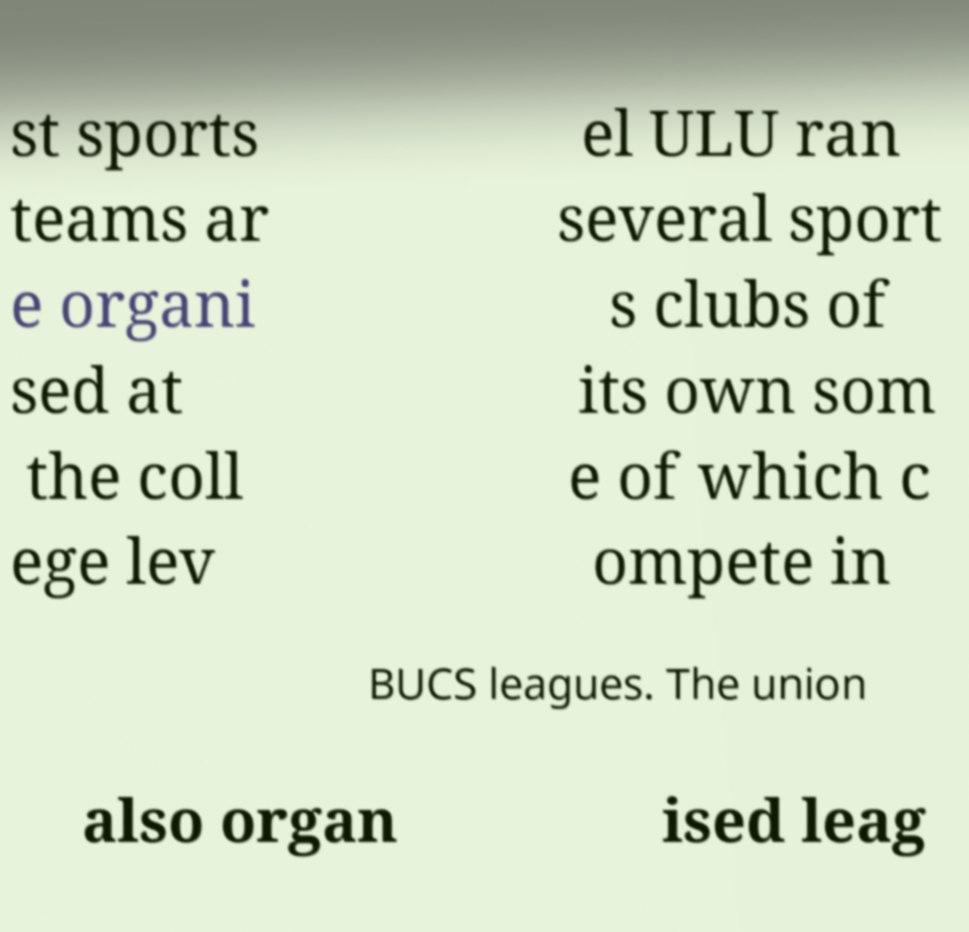Could you assist in decoding the text presented in this image and type it out clearly? st sports teams ar e organi sed at the coll ege lev el ULU ran several sport s clubs of its own som e of which c ompete in BUCS leagues. The union also organ ised leag 